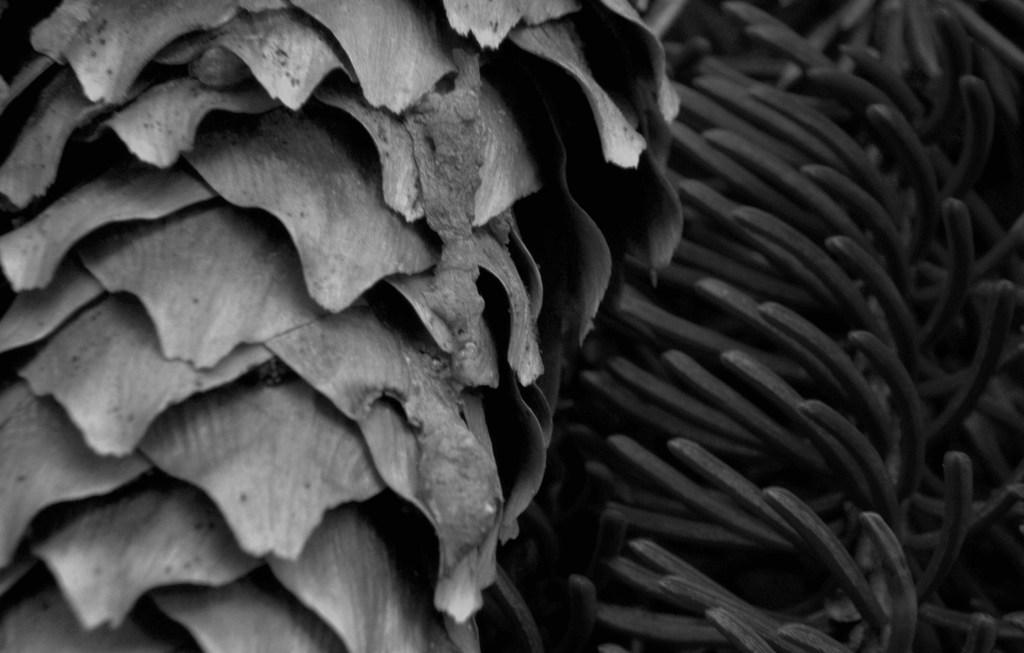What type of living organisms can be seen in the image? Plants can be seen in the image. What part of the plants is visible in the image? The leaves of the plants are visible in the image. What type of sock is being used to cream the lock in the image? There is no sock, cream, or lock present in the image. 